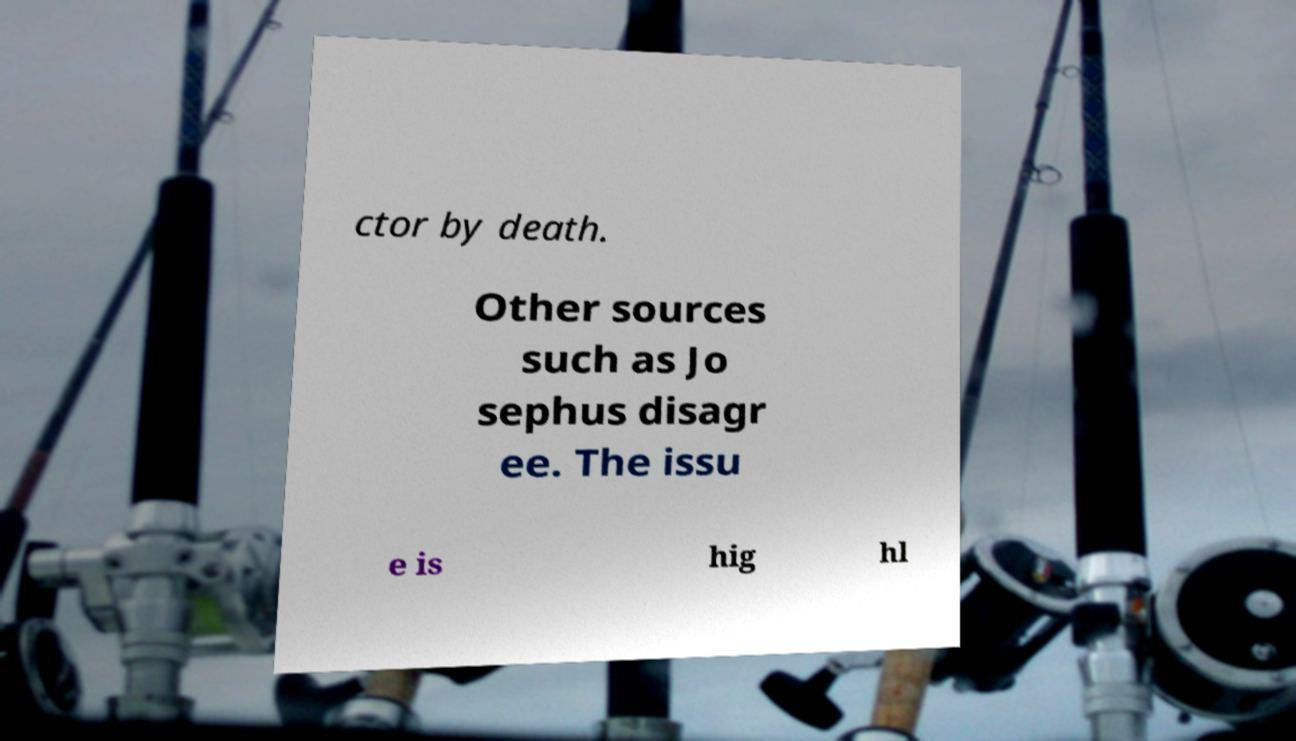There's text embedded in this image that I need extracted. Can you transcribe it verbatim? ctor by death. Other sources such as Jo sephus disagr ee. The issu e is hig hl 